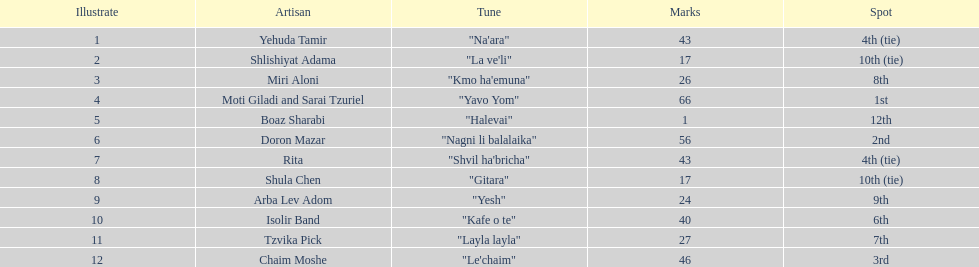Write the full table. {'header': ['Illustrate', 'Artisan', 'Tune', 'Marks', 'Spot'], 'rows': [['1', 'Yehuda Tamir', '"Na\'ara"', '43', '4th (tie)'], ['2', 'Shlishiyat Adama', '"La ve\'li"', '17', '10th (tie)'], ['3', 'Miri Aloni', '"Kmo ha\'emuna"', '26', '8th'], ['4', 'Moti Giladi and Sarai Tzuriel', '"Yavo Yom"', '66', '1st'], ['5', 'Boaz Sharabi', '"Halevai"', '1', '12th'], ['6', 'Doron Mazar', '"Nagni li balalaika"', '56', '2nd'], ['7', 'Rita', '"Shvil ha\'bricha"', '43', '4th (tie)'], ['8', 'Shula Chen', '"Gitara"', '17', '10th (tie)'], ['9', 'Arba Lev Adom', '"Yesh"', '24', '9th'], ['10', 'Isolir Band', '"Kafe o te"', '40', '6th'], ['11', 'Tzvika Pick', '"Layla layla"', '27', '7th'], ['12', 'Chaim Moshe', '"Le\'chaim"', '46', '3rd']]} Doron mazar, which artist(s) had the most points? Moti Giladi and Sarai Tzuriel. 